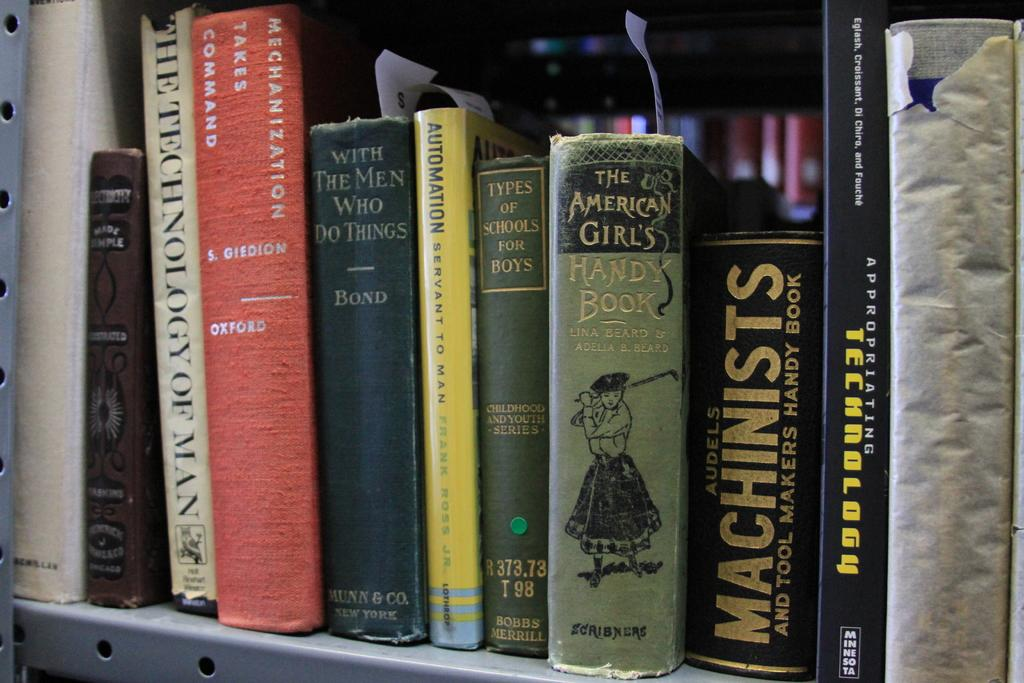<image>
Summarize the visual content of the image. A series of books is displayed including one titled "Types of Schools for Boys". 